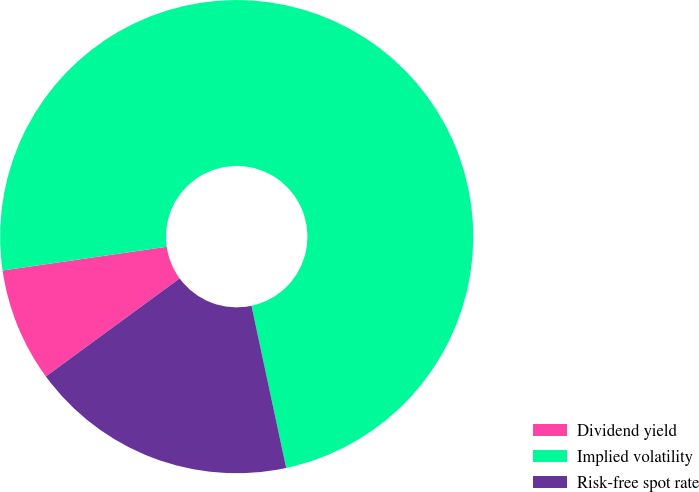Convert chart. <chart><loc_0><loc_0><loc_500><loc_500><pie_chart><fcel>Dividend yield<fcel>Implied volatility<fcel>Risk-free spot rate<nl><fcel>7.78%<fcel>73.93%<fcel>18.29%<nl></chart> 